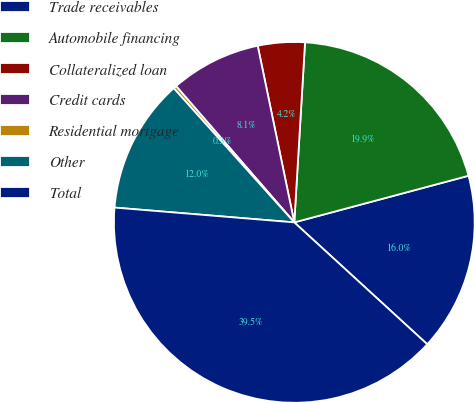Convert chart to OTSL. <chart><loc_0><loc_0><loc_500><loc_500><pie_chart><fcel>Trade receivables<fcel>Automobile financing<fcel>Collateralized loan<fcel>Credit cards<fcel>Residential mortgage<fcel>Other<fcel>Total<nl><fcel>15.97%<fcel>19.89%<fcel>4.2%<fcel>8.12%<fcel>0.28%<fcel>12.04%<fcel>39.5%<nl></chart> 